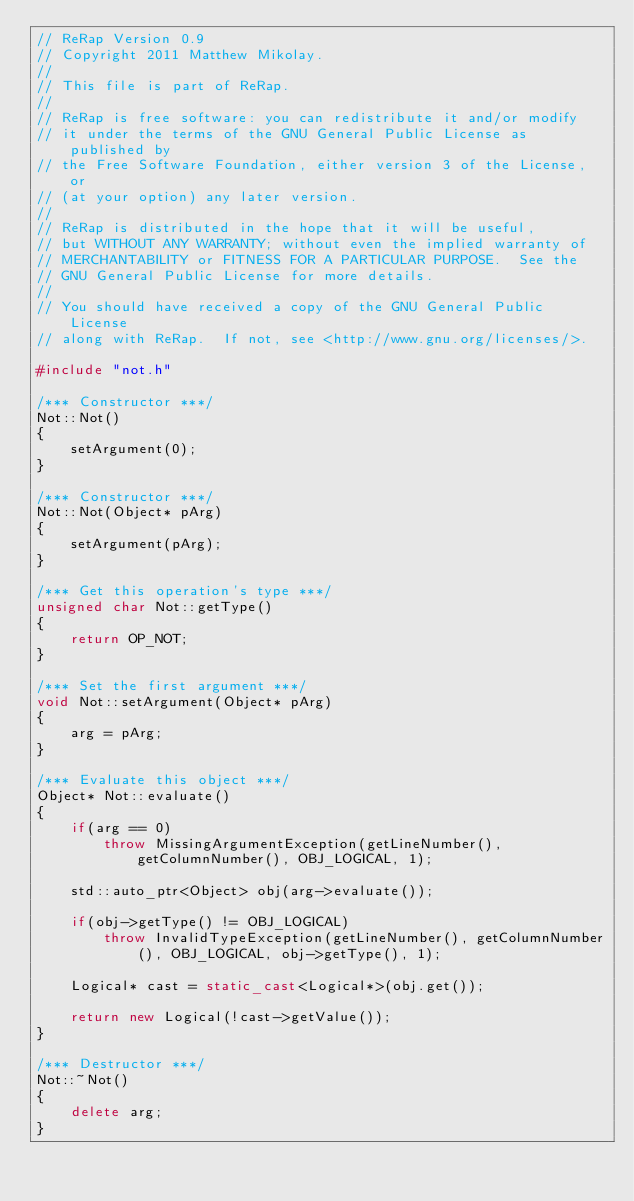<code> <loc_0><loc_0><loc_500><loc_500><_C++_>// ReRap Version 0.9
// Copyright 2011 Matthew Mikolay.
//
// This file is part of ReRap.
//
// ReRap is free software: you can redistribute it and/or modify
// it under the terms of the GNU General Public License as published by
// the Free Software Foundation, either version 3 of the License, or
// (at your option) any later version.
//
// ReRap is distributed in the hope that it will be useful,
// but WITHOUT ANY WARRANTY; without even the implied warranty of
// MERCHANTABILITY or FITNESS FOR A PARTICULAR PURPOSE.  See the
// GNU General Public License for more details.
//
// You should have received a copy of the GNU General Public License
// along with ReRap.  If not, see <http://www.gnu.org/licenses/>.

#include "not.h"

/*** Constructor ***/
Not::Not()
{
	setArgument(0);
}

/*** Constructor ***/
Not::Not(Object* pArg)
{
	setArgument(pArg);
}

/*** Get this operation's type ***/
unsigned char Not::getType()
{
	return OP_NOT;
}

/*** Set the first argument ***/
void Not::setArgument(Object* pArg)
{
	arg = pArg;
}

/*** Evaluate this object ***/
Object* Not::evaluate()
{
	if(arg == 0)
		throw MissingArgumentException(getLineNumber(), getColumnNumber(), OBJ_LOGICAL, 1);

	std::auto_ptr<Object> obj(arg->evaluate());

	if(obj->getType() != OBJ_LOGICAL)
		throw InvalidTypeException(getLineNumber(), getColumnNumber(), OBJ_LOGICAL, obj->getType(), 1);

	Logical* cast = static_cast<Logical*>(obj.get());

	return new Logical(!cast->getValue());
}

/*** Destructor ***/
Not::~Not()
{
	delete arg;
}
</code> 